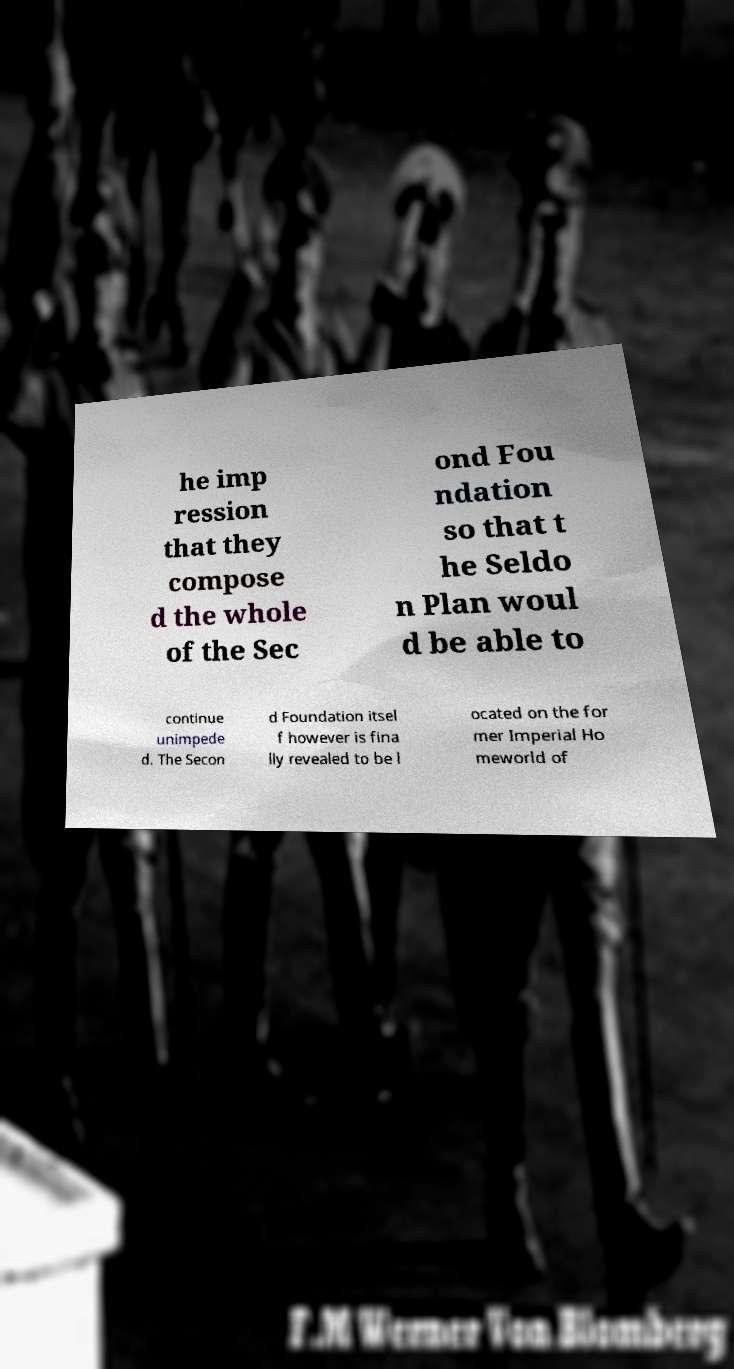I need the written content from this picture converted into text. Can you do that? he imp ression that they compose d the whole of the Sec ond Fou ndation so that t he Seldo n Plan woul d be able to continue unimpede d. The Secon d Foundation itsel f however is fina lly revealed to be l ocated on the for mer Imperial Ho meworld of 